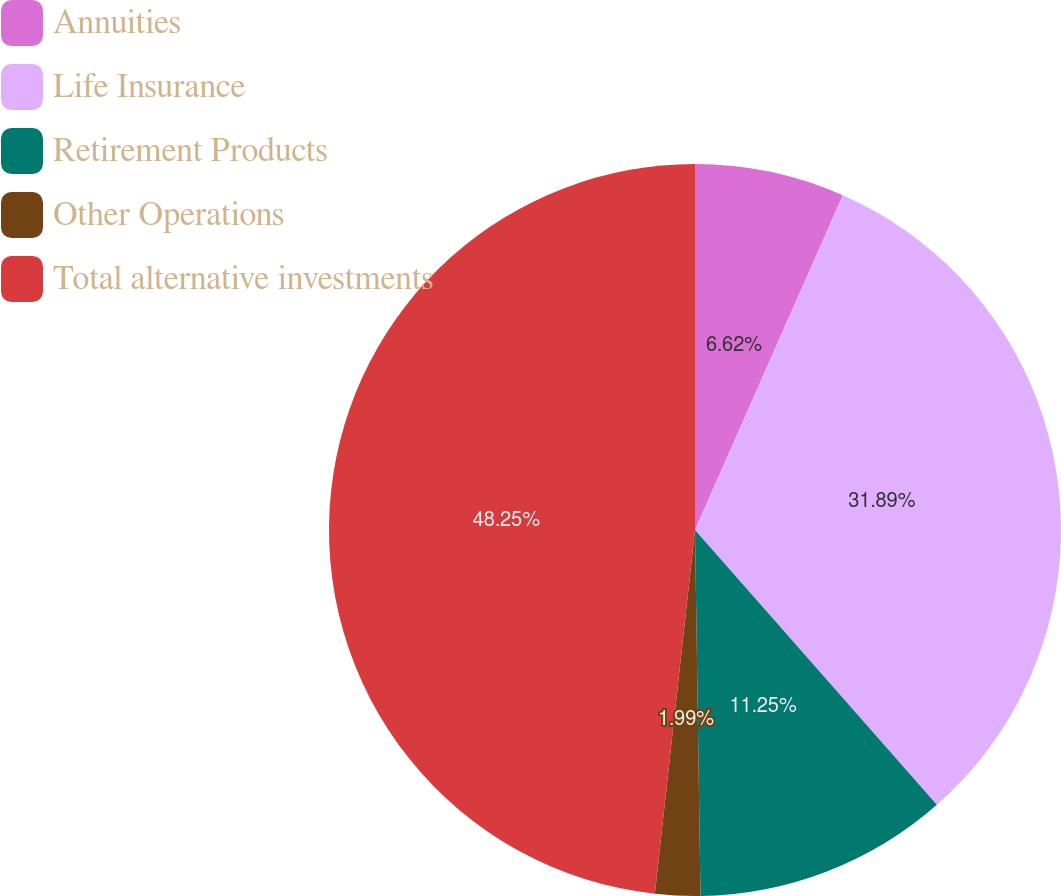Convert chart to OTSL. <chart><loc_0><loc_0><loc_500><loc_500><pie_chart><fcel>Annuities<fcel>Life Insurance<fcel>Retirement Products<fcel>Other Operations<fcel>Total alternative investments<nl><fcel>6.62%<fcel>31.89%<fcel>11.25%<fcel>1.99%<fcel>48.25%<nl></chart> 